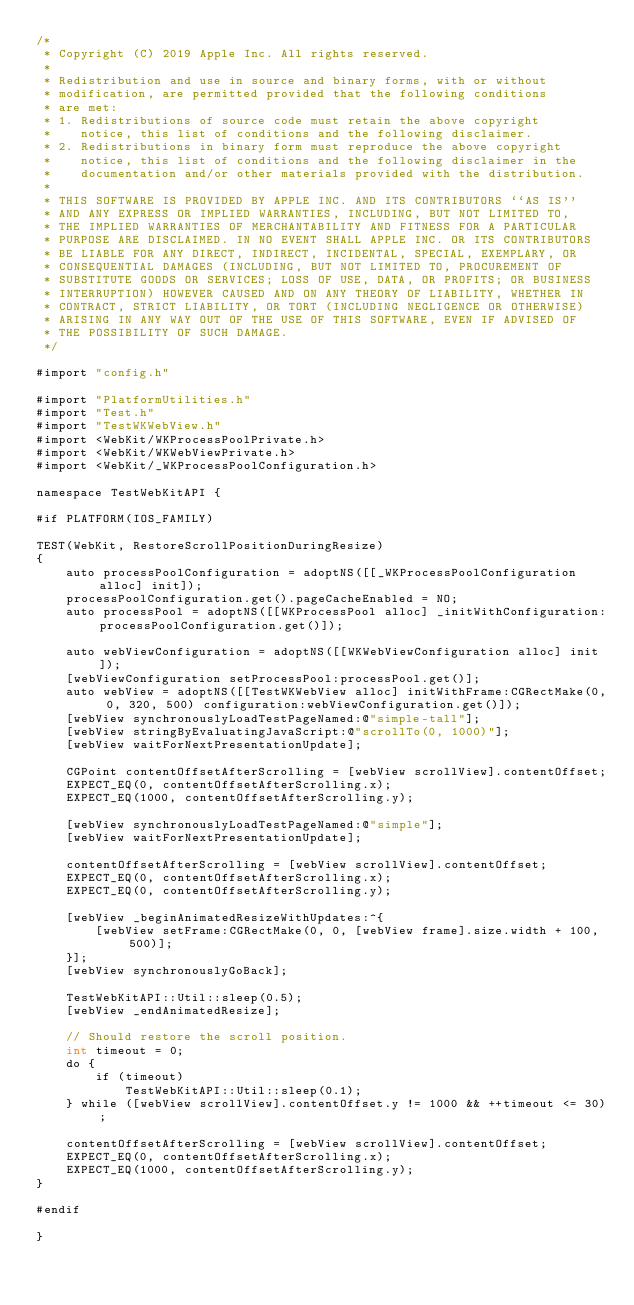Convert code to text. <code><loc_0><loc_0><loc_500><loc_500><_ObjectiveC_>/*
 * Copyright (C) 2019 Apple Inc. All rights reserved.
 *
 * Redistribution and use in source and binary forms, with or without
 * modification, are permitted provided that the following conditions
 * are met:
 * 1. Redistributions of source code must retain the above copyright
 *    notice, this list of conditions and the following disclaimer.
 * 2. Redistributions in binary form must reproduce the above copyright
 *    notice, this list of conditions and the following disclaimer in the
 *    documentation and/or other materials provided with the distribution.
 *
 * THIS SOFTWARE IS PROVIDED BY APPLE INC. AND ITS CONTRIBUTORS ``AS IS''
 * AND ANY EXPRESS OR IMPLIED WARRANTIES, INCLUDING, BUT NOT LIMITED TO,
 * THE IMPLIED WARRANTIES OF MERCHANTABILITY AND FITNESS FOR A PARTICULAR
 * PURPOSE ARE DISCLAIMED. IN NO EVENT SHALL APPLE INC. OR ITS CONTRIBUTORS
 * BE LIABLE FOR ANY DIRECT, INDIRECT, INCIDENTAL, SPECIAL, EXEMPLARY, OR
 * CONSEQUENTIAL DAMAGES (INCLUDING, BUT NOT LIMITED TO, PROCUREMENT OF
 * SUBSTITUTE GOODS OR SERVICES; LOSS OF USE, DATA, OR PROFITS; OR BUSINESS
 * INTERRUPTION) HOWEVER CAUSED AND ON ANY THEORY OF LIABILITY, WHETHER IN
 * CONTRACT, STRICT LIABILITY, OR TORT (INCLUDING NEGLIGENCE OR OTHERWISE)
 * ARISING IN ANY WAY OUT OF THE USE OF THIS SOFTWARE, EVEN IF ADVISED OF
 * THE POSSIBILITY OF SUCH DAMAGE.
 */

#import "config.h"

#import "PlatformUtilities.h"
#import "Test.h"
#import "TestWKWebView.h"
#import <WebKit/WKProcessPoolPrivate.h>
#import <WebKit/WKWebViewPrivate.h>
#import <WebKit/_WKProcessPoolConfiguration.h>

namespace TestWebKitAPI {

#if PLATFORM(IOS_FAMILY)

TEST(WebKit, RestoreScrollPositionDuringResize)
{
    auto processPoolConfiguration = adoptNS([[_WKProcessPoolConfiguration alloc] init]);
    processPoolConfiguration.get().pageCacheEnabled = NO;
    auto processPool = adoptNS([[WKProcessPool alloc] _initWithConfiguration:processPoolConfiguration.get()]);

    auto webViewConfiguration = adoptNS([[WKWebViewConfiguration alloc] init]);
    [webViewConfiguration setProcessPool:processPool.get()];
    auto webView = adoptNS([[TestWKWebView alloc] initWithFrame:CGRectMake(0, 0, 320, 500) configuration:webViewConfiguration.get()]);
    [webView synchronouslyLoadTestPageNamed:@"simple-tall"];
    [webView stringByEvaluatingJavaScript:@"scrollTo(0, 1000)"];
    [webView waitForNextPresentationUpdate];

    CGPoint contentOffsetAfterScrolling = [webView scrollView].contentOffset;
    EXPECT_EQ(0, contentOffsetAfterScrolling.x);
    EXPECT_EQ(1000, contentOffsetAfterScrolling.y);

    [webView synchronouslyLoadTestPageNamed:@"simple"];
    [webView waitForNextPresentationUpdate];

    contentOffsetAfterScrolling = [webView scrollView].contentOffset;
    EXPECT_EQ(0, contentOffsetAfterScrolling.x);
    EXPECT_EQ(0, contentOffsetAfterScrolling.y);

    [webView _beginAnimatedResizeWithUpdates:^{
        [webView setFrame:CGRectMake(0, 0, [webView frame].size.width + 100, 500)];
    }];
    [webView synchronouslyGoBack];

    TestWebKitAPI::Util::sleep(0.5);
    [webView _endAnimatedResize];

    // Should restore the scroll position.
    int timeout = 0;
    do {
        if (timeout)
            TestWebKitAPI::Util::sleep(0.1);
    } while ([webView scrollView].contentOffset.y != 1000 && ++timeout <= 30);

    contentOffsetAfterScrolling = [webView scrollView].contentOffset;
    EXPECT_EQ(0, contentOffsetAfterScrolling.x);
    EXPECT_EQ(1000, contentOffsetAfterScrolling.y);
}

#endif

}
</code> 